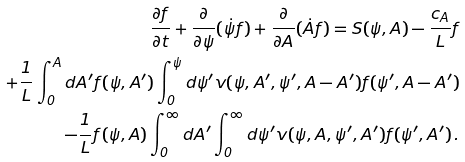<formula> <loc_0><loc_0><loc_500><loc_500>{ \frac { \partial f } { \partial t } + \frac { \partial } { \partial \psi } ( \dot { \psi } f ) + \frac { \partial } { \partial A } ( \dot { A } f ) = S ( \psi , A ) - \frac { c _ { A } } { L } f } \\ + \frac { 1 } { L } \int _ { 0 } ^ { A } d A ^ { \prime } f ( \psi , A ^ { \prime } ) \int _ { 0 } ^ { \psi } d \psi ^ { \prime } v ( \psi , A ^ { \prime } , \psi ^ { \prime } , A - A ^ { \prime } ) f ( \psi ^ { \prime } , A - A ^ { \prime } ) \\ - \frac { 1 } { L } f ( \psi , A ) \int _ { 0 } ^ { \infty } d A ^ { \prime } \int _ { 0 } ^ { \infty } d \psi ^ { \prime } v ( \psi , A , \psi ^ { \prime } , A ^ { \prime } ) f ( \psi ^ { \prime } , A ^ { \prime } ) \, .</formula> 